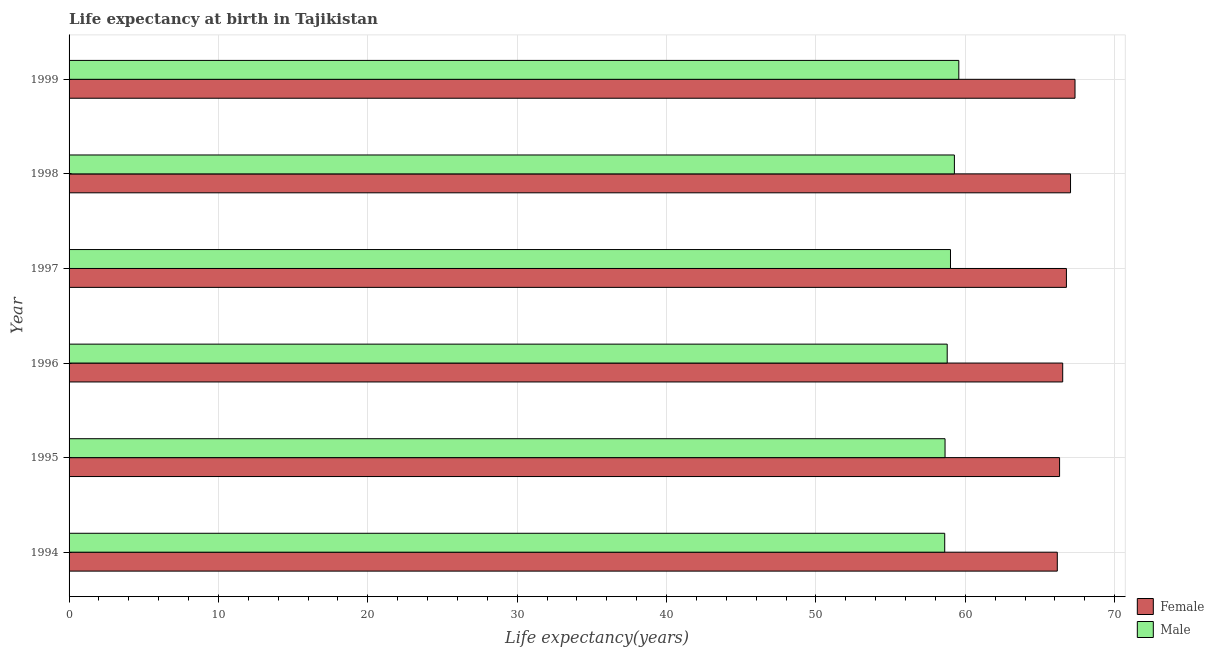How many groups of bars are there?
Your answer should be compact. 6. Are the number of bars on each tick of the Y-axis equal?
Give a very brief answer. Yes. What is the label of the 3rd group of bars from the top?
Keep it short and to the point. 1997. In how many cases, is the number of bars for a given year not equal to the number of legend labels?
Offer a very short reply. 0. What is the life expectancy(male) in 1998?
Provide a succinct answer. 59.27. Across all years, what is the maximum life expectancy(female)?
Offer a terse response. 67.35. Across all years, what is the minimum life expectancy(male)?
Provide a succinct answer. 58.62. In which year was the life expectancy(male) maximum?
Offer a terse response. 1999. In which year was the life expectancy(male) minimum?
Your answer should be very brief. 1994. What is the total life expectancy(male) in the graph?
Provide a short and direct response. 353.92. What is the difference between the life expectancy(female) in 1995 and that in 1999?
Your response must be concise. -1.03. What is the difference between the life expectancy(male) in 1995 and the life expectancy(female) in 1997?
Give a very brief answer. -8.13. What is the average life expectancy(male) per year?
Make the answer very short. 58.99. In the year 1996, what is the difference between the life expectancy(male) and life expectancy(female)?
Your answer should be compact. -7.73. What is the ratio of the life expectancy(female) in 1996 to that in 1999?
Your response must be concise. 0.99. In how many years, is the life expectancy(male) greater than the average life expectancy(male) taken over all years?
Ensure brevity in your answer.  3. Is the sum of the life expectancy(male) in 1994 and 1998 greater than the maximum life expectancy(female) across all years?
Provide a succinct answer. Yes. What does the 1st bar from the bottom in 1999 represents?
Provide a short and direct response. Female. Are all the bars in the graph horizontal?
Give a very brief answer. Yes. How many years are there in the graph?
Provide a short and direct response. 6. What is the difference between two consecutive major ticks on the X-axis?
Provide a short and direct response. 10. Are the values on the major ticks of X-axis written in scientific E-notation?
Make the answer very short. No. Does the graph contain any zero values?
Keep it short and to the point. No. Does the graph contain grids?
Make the answer very short. Yes. What is the title of the graph?
Ensure brevity in your answer.  Life expectancy at birth in Tajikistan. Does "Excluding technical cooperation" appear as one of the legend labels in the graph?
Your answer should be compact. No. What is the label or title of the X-axis?
Give a very brief answer. Life expectancy(years). What is the label or title of the Y-axis?
Ensure brevity in your answer.  Year. What is the Life expectancy(years) in Female in 1994?
Make the answer very short. 66.16. What is the Life expectancy(years) of Male in 1994?
Your answer should be compact. 58.62. What is the Life expectancy(years) of Female in 1995?
Ensure brevity in your answer.  66.31. What is the Life expectancy(years) in Male in 1995?
Offer a terse response. 58.65. What is the Life expectancy(years) of Female in 1996?
Offer a very short reply. 66.52. What is the Life expectancy(years) in Male in 1996?
Make the answer very short. 58.79. What is the Life expectancy(years) in Female in 1997?
Make the answer very short. 66.77. What is the Life expectancy(years) of Male in 1997?
Make the answer very short. 59.01. What is the Life expectancy(years) of Female in 1998?
Ensure brevity in your answer.  67.05. What is the Life expectancy(years) in Male in 1998?
Your answer should be compact. 59.27. What is the Life expectancy(years) of Female in 1999?
Ensure brevity in your answer.  67.35. What is the Life expectancy(years) of Male in 1999?
Make the answer very short. 59.57. Across all years, what is the maximum Life expectancy(years) in Female?
Give a very brief answer. 67.35. Across all years, what is the maximum Life expectancy(years) of Male?
Offer a terse response. 59.57. Across all years, what is the minimum Life expectancy(years) of Female?
Offer a terse response. 66.16. Across all years, what is the minimum Life expectancy(years) in Male?
Make the answer very short. 58.62. What is the total Life expectancy(years) in Female in the graph?
Your answer should be compact. 400.17. What is the total Life expectancy(years) in Male in the graph?
Keep it short and to the point. 353.92. What is the difference between the Life expectancy(years) in Female in 1994 and that in 1995?
Keep it short and to the point. -0.15. What is the difference between the Life expectancy(years) of Male in 1994 and that in 1995?
Offer a very short reply. -0.02. What is the difference between the Life expectancy(years) of Female in 1994 and that in 1996?
Provide a succinct answer. -0.36. What is the difference between the Life expectancy(years) of Male in 1994 and that in 1996?
Your answer should be very brief. -0.17. What is the difference between the Life expectancy(years) of Female in 1994 and that in 1997?
Your answer should be very brief. -0.61. What is the difference between the Life expectancy(years) in Male in 1994 and that in 1997?
Ensure brevity in your answer.  -0.39. What is the difference between the Life expectancy(years) of Female in 1994 and that in 1998?
Offer a terse response. -0.89. What is the difference between the Life expectancy(years) in Male in 1994 and that in 1998?
Provide a short and direct response. -0.65. What is the difference between the Life expectancy(years) in Female in 1994 and that in 1999?
Your answer should be very brief. -1.19. What is the difference between the Life expectancy(years) of Male in 1994 and that in 1999?
Offer a terse response. -0.94. What is the difference between the Life expectancy(years) in Female in 1995 and that in 1996?
Provide a succinct answer. -0.21. What is the difference between the Life expectancy(years) of Male in 1995 and that in 1996?
Provide a succinct answer. -0.14. What is the difference between the Life expectancy(years) of Female in 1995 and that in 1997?
Give a very brief answer. -0.46. What is the difference between the Life expectancy(years) of Male in 1995 and that in 1997?
Make the answer very short. -0.36. What is the difference between the Life expectancy(years) in Female in 1995 and that in 1998?
Give a very brief answer. -0.73. What is the difference between the Life expectancy(years) in Male in 1995 and that in 1998?
Your response must be concise. -0.63. What is the difference between the Life expectancy(years) of Female in 1995 and that in 1999?
Your response must be concise. -1.03. What is the difference between the Life expectancy(years) in Male in 1995 and that in 1999?
Your answer should be compact. -0.92. What is the difference between the Life expectancy(years) of Female in 1996 and that in 1997?
Your response must be concise. -0.25. What is the difference between the Life expectancy(years) in Male in 1996 and that in 1997?
Provide a succinct answer. -0.22. What is the difference between the Life expectancy(years) of Female in 1996 and that in 1998?
Provide a succinct answer. -0.52. What is the difference between the Life expectancy(years) in Male in 1996 and that in 1998?
Your answer should be very brief. -0.48. What is the difference between the Life expectancy(years) in Female in 1996 and that in 1999?
Your response must be concise. -0.82. What is the difference between the Life expectancy(years) of Male in 1996 and that in 1999?
Your answer should be compact. -0.78. What is the difference between the Life expectancy(years) of Female in 1997 and that in 1998?
Give a very brief answer. -0.28. What is the difference between the Life expectancy(years) of Male in 1997 and that in 1998?
Your answer should be compact. -0.26. What is the difference between the Life expectancy(years) in Female in 1997 and that in 1999?
Make the answer very short. -0.57. What is the difference between the Life expectancy(years) in Male in 1997 and that in 1999?
Your answer should be compact. -0.56. What is the difference between the Life expectancy(years) of Male in 1998 and that in 1999?
Offer a very short reply. -0.3. What is the difference between the Life expectancy(years) of Female in 1994 and the Life expectancy(years) of Male in 1995?
Provide a succinct answer. 7.51. What is the difference between the Life expectancy(years) in Female in 1994 and the Life expectancy(years) in Male in 1996?
Give a very brief answer. 7.37. What is the difference between the Life expectancy(years) of Female in 1994 and the Life expectancy(years) of Male in 1997?
Ensure brevity in your answer.  7.15. What is the difference between the Life expectancy(years) in Female in 1994 and the Life expectancy(years) in Male in 1998?
Make the answer very short. 6.89. What is the difference between the Life expectancy(years) in Female in 1994 and the Life expectancy(years) in Male in 1999?
Keep it short and to the point. 6.59. What is the difference between the Life expectancy(years) in Female in 1995 and the Life expectancy(years) in Male in 1996?
Offer a very short reply. 7.52. What is the difference between the Life expectancy(years) in Female in 1995 and the Life expectancy(years) in Male in 1997?
Keep it short and to the point. 7.3. What is the difference between the Life expectancy(years) in Female in 1995 and the Life expectancy(years) in Male in 1998?
Your answer should be very brief. 7.04. What is the difference between the Life expectancy(years) in Female in 1995 and the Life expectancy(years) in Male in 1999?
Provide a succinct answer. 6.75. What is the difference between the Life expectancy(years) of Female in 1996 and the Life expectancy(years) of Male in 1997?
Your response must be concise. 7.51. What is the difference between the Life expectancy(years) in Female in 1996 and the Life expectancy(years) in Male in 1998?
Your answer should be very brief. 7.25. What is the difference between the Life expectancy(years) in Female in 1996 and the Life expectancy(years) in Male in 1999?
Provide a short and direct response. 6.96. What is the difference between the Life expectancy(years) in Female in 1997 and the Life expectancy(years) in Male in 1998?
Ensure brevity in your answer.  7.5. What is the difference between the Life expectancy(years) of Female in 1997 and the Life expectancy(years) of Male in 1999?
Offer a terse response. 7.2. What is the difference between the Life expectancy(years) in Female in 1998 and the Life expectancy(years) in Male in 1999?
Your answer should be very brief. 7.48. What is the average Life expectancy(years) in Female per year?
Your response must be concise. 66.69. What is the average Life expectancy(years) of Male per year?
Provide a short and direct response. 58.99. In the year 1994, what is the difference between the Life expectancy(years) in Female and Life expectancy(years) in Male?
Provide a succinct answer. 7.54. In the year 1995, what is the difference between the Life expectancy(years) of Female and Life expectancy(years) of Male?
Your response must be concise. 7.67. In the year 1996, what is the difference between the Life expectancy(years) in Female and Life expectancy(years) in Male?
Provide a succinct answer. 7.73. In the year 1997, what is the difference between the Life expectancy(years) of Female and Life expectancy(years) of Male?
Make the answer very short. 7.76. In the year 1998, what is the difference between the Life expectancy(years) of Female and Life expectancy(years) of Male?
Provide a short and direct response. 7.78. In the year 1999, what is the difference between the Life expectancy(years) in Female and Life expectancy(years) in Male?
Offer a terse response. 7.78. What is the ratio of the Life expectancy(years) of Female in 1994 to that in 1995?
Make the answer very short. 1. What is the ratio of the Life expectancy(years) of Female in 1994 to that in 1996?
Provide a short and direct response. 0.99. What is the ratio of the Life expectancy(years) in Male in 1994 to that in 1996?
Offer a terse response. 1. What is the ratio of the Life expectancy(years) in Female in 1994 to that in 1997?
Keep it short and to the point. 0.99. What is the ratio of the Life expectancy(years) of Male in 1994 to that in 1997?
Make the answer very short. 0.99. What is the ratio of the Life expectancy(years) of Male in 1994 to that in 1998?
Offer a very short reply. 0.99. What is the ratio of the Life expectancy(years) of Female in 1994 to that in 1999?
Make the answer very short. 0.98. What is the ratio of the Life expectancy(years) in Male in 1994 to that in 1999?
Make the answer very short. 0.98. What is the ratio of the Life expectancy(years) of Male in 1995 to that in 1996?
Your answer should be very brief. 1. What is the ratio of the Life expectancy(years) of Female in 1995 to that in 1997?
Ensure brevity in your answer.  0.99. What is the ratio of the Life expectancy(years) in Male in 1995 to that in 1997?
Offer a very short reply. 0.99. What is the ratio of the Life expectancy(years) of Female in 1995 to that in 1998?
Make the answer very short. 0.99. What is the ratio of the Life expectancy(years) of Female in 1995 to that in 1999?
Your answer should be compact. 0.98. What is the ratio of the Life expectancy(years) of Male in 1995 to that in 1999?
Make the answer very short. 0.98. What is the ratio of the Life expectancy(years) in Female in 1996 to that in 1997?
Your response must be concise. 1. What is the ratio of the Life expectancy(years) of Male in 1996 to that in 1998?
Keep it short and to the point. 0.99. What is the ratio of the Life expectancy(years) of Male in 1996 to that in 1999?
Provide a short and direct response. 0.99. What is the ratio of the Life expectancy(years) in Male in 1997 to that in 1998?
Ensure brevity in your answer.  1. What is the ratio of the Life expectancy(years) in Female in 1997 to that in 1999?
Your answer should be compact. 0.99. What is the ratio of the Life expectancy(years) of Male in 1997 to that in 1999?
Your response must be concise. 0.99. What is the ratio of the Life expectancy(years) in Female in 1998 to that in 1999?
Give a very brief answer. 1. What is the difference between the highest and the second highest Life expectancy(years) of Female?
Your response must be concise. 0.3. What is the difference between the highest and the second highest Life expectancy(years) of Male?
Provide a succinct answer. 0.3. What is the difference between the highest and the lowest Life expectancy(years) of Female?
Provide a succinct answer. 1.19. What is the difference between the highest and the lowest Life expectancy(years) in Male?
Give a very brief answer. 0.94. 